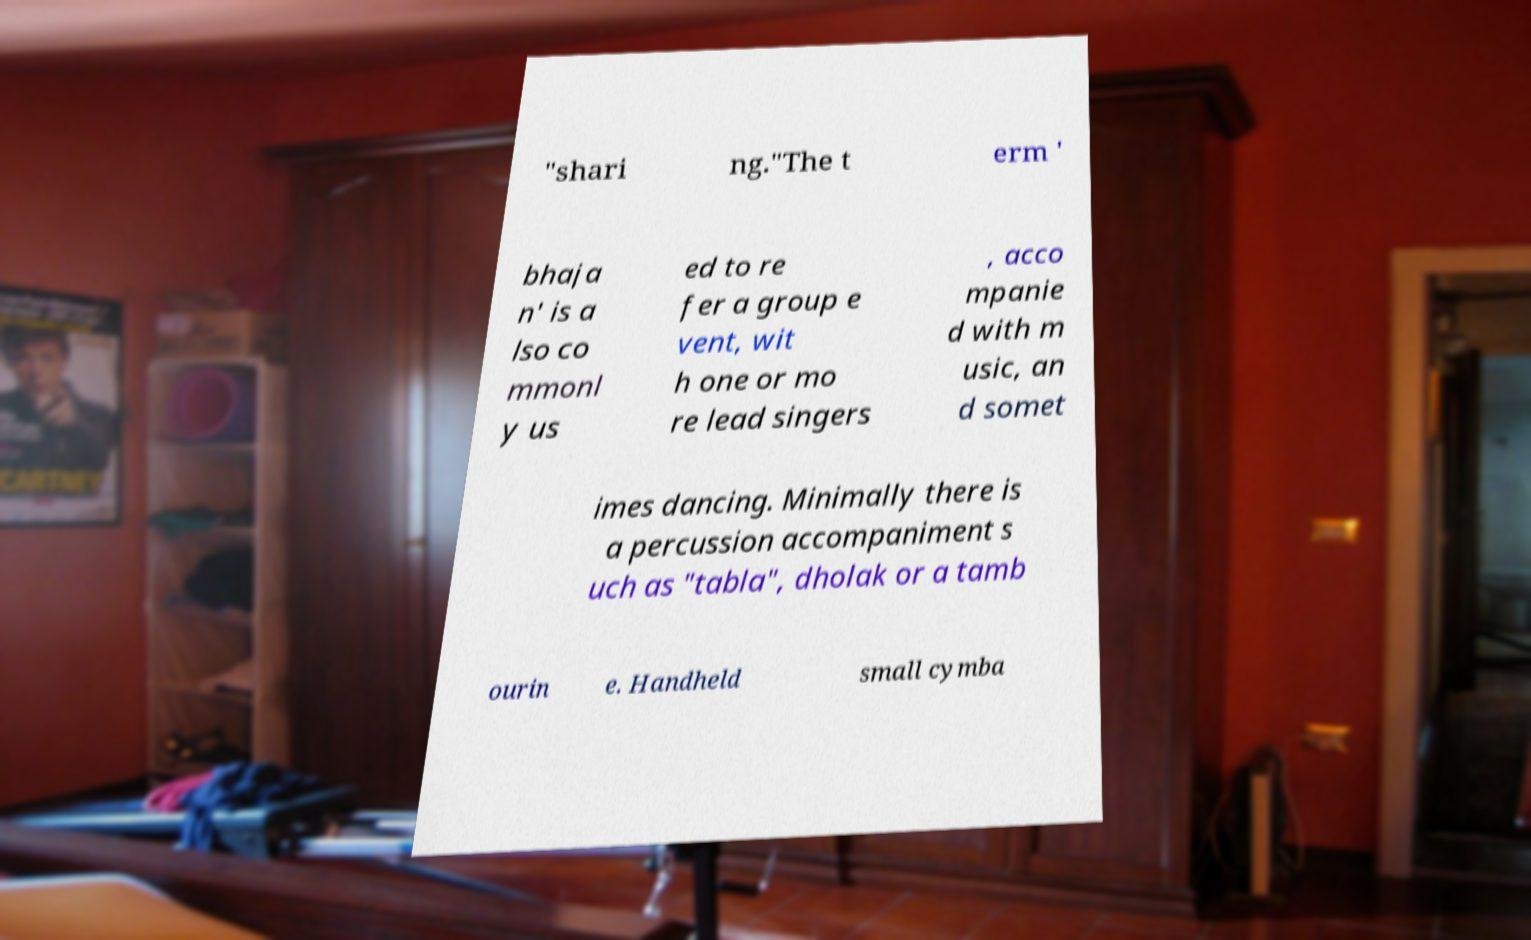Please read and relay the text visible in this image. What does it say? "shari ng."The t erm ' bhaja n' is a lso co mmonl y us ed to re fer a group e vent, wit h one or mo re lead singers , acco mpanie d with m usic, an d somet imes dancing. Minimally there is a percussion accompaniment s uch as "tabla", dholak or a tamb ourin e. Handheld small cymba 